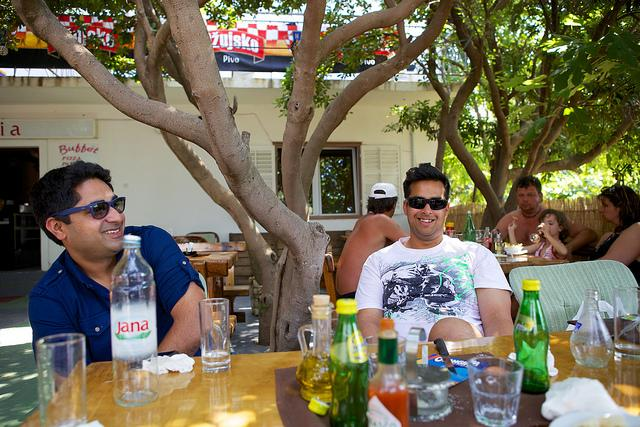What establishment is located behind the people? Please explain your reasoning. restaurant. People sit on the patio of a business that is behind them with a sign on the top. people sit outside when they eat at restaurants on nice days. 